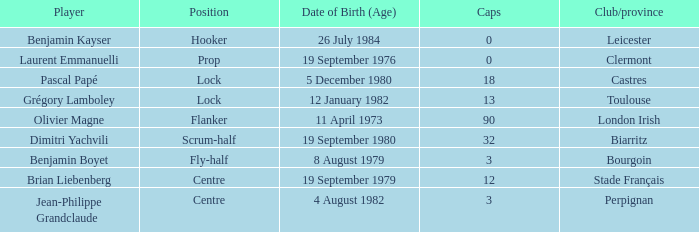Which individual has a cap count exceeding 12 and belongs to clubs of toulouse? Grégory Lamboley. 